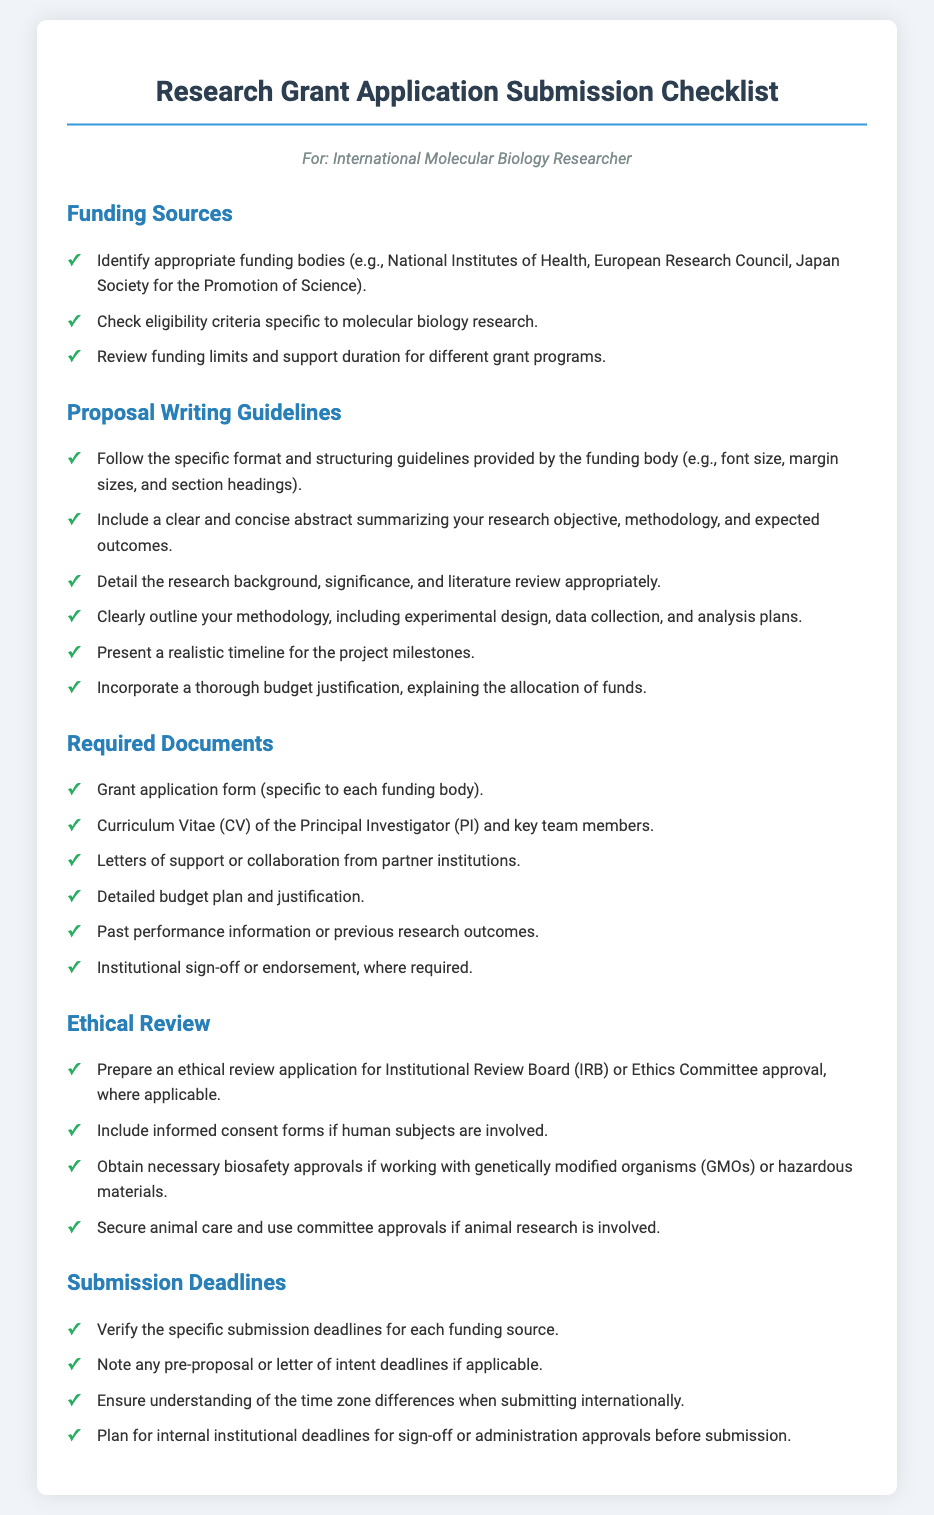What are some examples of funding bodies? The funding bodies mentioned in the document include the National Institutes of Health, European Research Council, and Japan Society for the Promotion of Science.
Answer: National Institutes of Health, European Research Council, Japan Society for the Promotion of Science What must be included in the proposal's abstract? The abstract should summarize your research objective, methodology, and expected outcomes clearly and concisely.
Answer: Research objective, methodology, expected outcomes What is one required document for submitting a grant application? The document specifies a grant application form, which is specific to each funding body.
Answer: Grant application form What approvals are needed for ethical review in animal research? The document states that secure animal care and use committee approvals are required for animal research.
Answer: Animal care and use committee approvals What should be verified regarding submission deadlines? The document indicates that one must verify the specific submission deadlines for each funding source.
Answer: Specific submission deadlines What must be included if human subjects are involved? The document states that informed consent forms must be included if human subjects are involved.
Answer: Informed consent forms What type of justification must be included in the budget? The document mentions a thorough budget justification, explaining the allocation of funds.
Answer: Budget justification What phrase describes the required content for the research methodology section? The methodology section should outline your methodology, including experimental design, data collection, and analysis plans.
Answer: Experimental design, data collection, analysis plans What is a necessary document related to team qualifications? The document requires including the Curriculum Vitae (CV) of the Principal Investigator (PI) and key team members.
Answer: Curriculum Vitae (CV) 